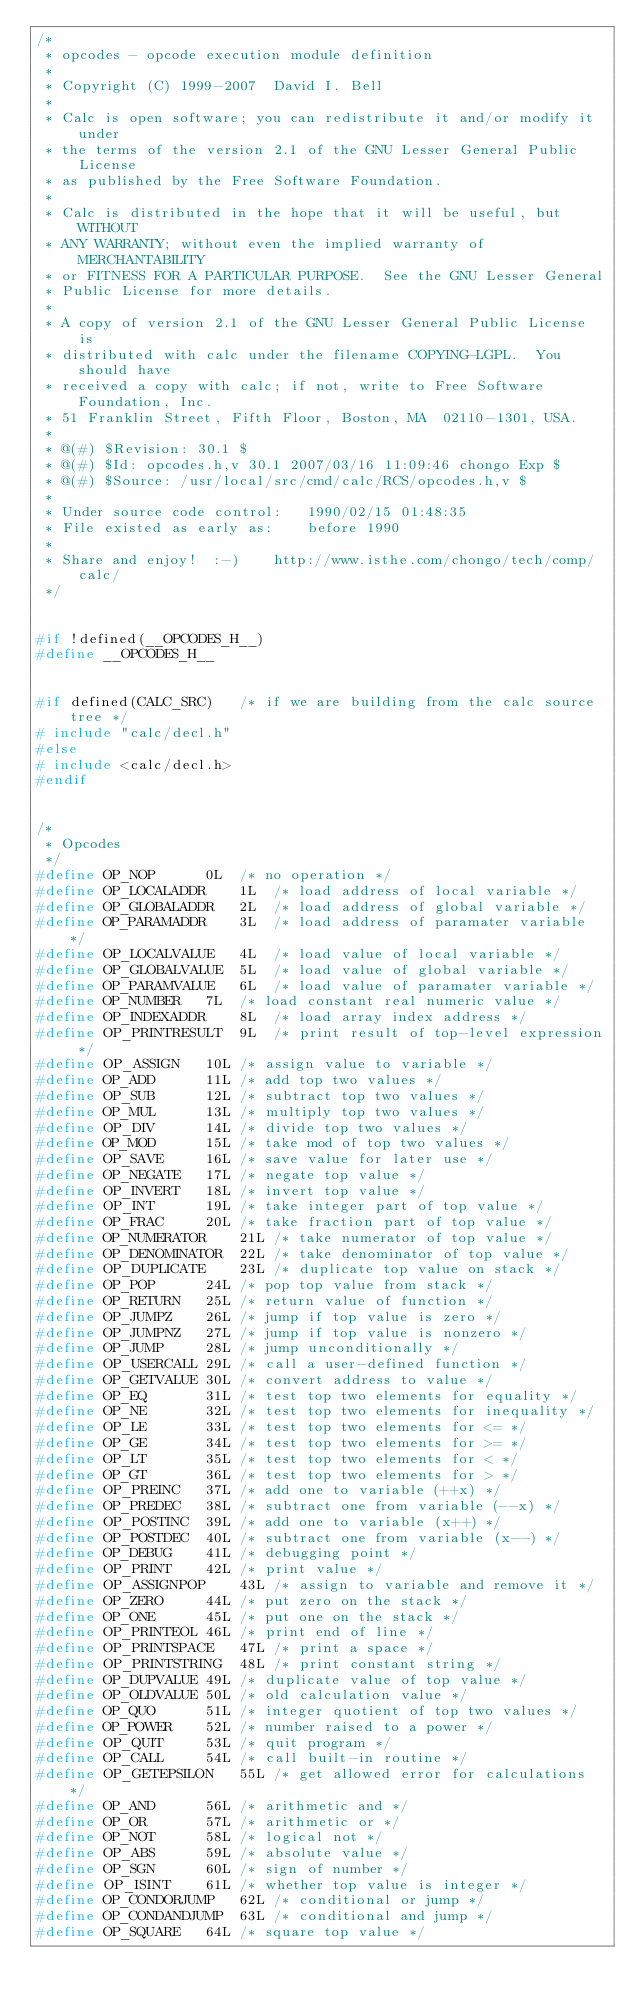<code> <loc_0><loc_0><loc_500><loc_500><_C_>/*
 * opcodes - opcode execution module definition
 *
 * Copyright (C) 1999-2007  David I. Bell
 *
 * Calc is open software; you can redistribute it and/or modify it under
 * the terms of the version 2.1 of the GNU Lesser General Public License
 * as published by the Free Software Foundation.
 *
 * Calc is distributed in the hope that it will be useful, but WITHOUT
 * ANY WARRANTY; without even the implied warranty of MERCHANTABILITY
 * or FITNESS FOR A PARTICULAR PURPOSE.	 See the GNU Lesser General
 * Public License for more details.
 *
 * A copy of version 2.1 of the GNU Lesser General Public License is
 * distributed with calc under the filename COPYING-LGPL.  You should have
 * received a copy with calc; if not, write to Free Software Foundation, Inc.
 * 51 Franklin Street, Fifth Floor, Boston, MA  02110-1301, USA.
 *
 * @(#) $Revision: 30.1 $
 * @(#) $Id: opcodes.h,v 30.1 2007/03/16 11:09:46 chongo Exp $
 * @(#) $Source: /usr/local/src/cmd/calc/RCS/opcodes.h,v $
 *
 * Under source code control:	1990/02/15 01:48:35
 * File existed as early as:	before 1990
 *
 * Share and enjoy!  :-)	http://www.isthe.com/chongo/tech/comp/calc/
 */


#if !defined(__OPCODES_H__)
#define __OPCODES_H__


#if defined(CALC_SRC)	/* if we are building from the calc source tree */
# include "calc/decl.h"
#else
# include <calc/decl.h>
#endif


/*
 * Opcodes
 */
#define OP_NOP		0L	/* no operation */
#define OP_LOCALADDR	1L	/* load address of local variable */
#define OP_GLOBALADDR	2L	/* load address of global variable */
#define OP_PARAMADDR	3L	/* load address of paramater variable */
#define OP_LOCALVALUE	4L	/* load value of local variable */
#define OP_GLOBALVALUE	5L	/* load value of global variable */
#define OP_PARAMVALUE	6L	/* load value of paramater variable */
#define OP_NUMBER	7L	/* load constant real numeric value */
#define OP_INDEXADDR	8L	/* load array index address */
#define OP_PRINTRESULT	9L	/* print result of top-level expression */
#define OP_ASSIGN	10L	/* assign value to variable */
#define OP_ADD		11L	/* add top two values */
#define OP_SUB		12L	/* subtract top two values */
#define OP_MUL		13L	/* multiply top two values */
#define OP_DIV		14L	/* divide top two values */
#define OP_MOD		15L	/* take mod of top two values */
#define OP_SAVE		16L	/* save value for later use */
#define OP_NEGATE	17L	/* negate top value */
#define OP_INVERT	18L	/* invert top value */
#define OP_INT		19L	/* take integer part of top value */
#define OP_FRAC		20L	/* take fraction part of top value */
#define OP_NUMERATOR	21L	/* take numerator of top value */
#define OP_DENOMINATOR	22L	/* take denominator of top value */
#define OP_DUPLICATE	23L	/* duplicate top value on stack */
#define OP_POP		24L	/* pop top value from stack */
#define OP_RETURN	25L	/* return value of function */
#define OP_JUMPZ	26L	/* jump if top value is zero */
#define OP_JUMPNZ	27L	/* jump if top value is nonzero */
#define OP_JUMP		28L	/* jump unconditionally */
#define OP_USERCALL	29L	/* call a user-defined function */
#define OP_GETVALUE	30L	/* convert address to value */
#define OP_EQ		31L	/* test top two elements for equality */
#define OP_NE		32L	/* test top two elements for inequality */
#define OP_LE		33L	/* test top two elements for <= */
#define OP_GE		34L	/* test top two elements for >= */
#define OP_LT		35L	/* test top two elements for < */
#define OP_GT		36L	/* test top two elements for > */
#define OP_PREINC	37L	/* add one to variable (++x) */
#define OP_PREDEC	38L	/* subtract one from variable (--x) */
#define OP_POSTINC	39L	/* add one to variable (x++) */
#define OP_POSTDEC	40L	/* subtract one from variable (x--) */
#define OP_DEBUG	41L	/* debugging point */
#define OP_PRINT	42L	/* print value */
#define OP_ASSIGNPOP	43L	/* assign to variable and remove it */
#define OP_ZERO		44L	/* put zero on the stack */
#define OP_ONE		45L	/* put one on the stack */
#define OP_PRINTEOL	46L	/* print end of line */
#define OP_PRINTSPACE	47L	/* print a space */
#define OP_PRINTSTRING	48L	/* print constant string */
#define OP_DUPVALUE	49L	/* duplicate value of top value */
#define OP_OLDVALUE	50L	/* old calculation value */
#define OP_QUO		51L	/* integer quotient of top two values */
#define OP_POWER	52L	/* number raised to a power */
#define OP_QUIT		53L	/* quit program */
#define OP_CALL		54L	/* call built-in routine */
#define OP_GETEPSILON	55L	/* get allowed error for calculations */
#define OP_AND		56L	/* arithmetic and */
#define OP_OR		57L	/* arithmetic or */
#define OP_NOT		58L	/* logical not */
#define OP_ABS		59L	/* absolute value */
#define OP_SGN		60L	/* sign of number */
#define OP_ISINT	61L	/* whether top value is integer */
#define OP_CONDORJUMP	62L	/* conditional or jump */
#define OP_CONDANDJUMP	63L	/* conditional and jump */
#define OP_SQUARE	64L	/* square top value */</code> 